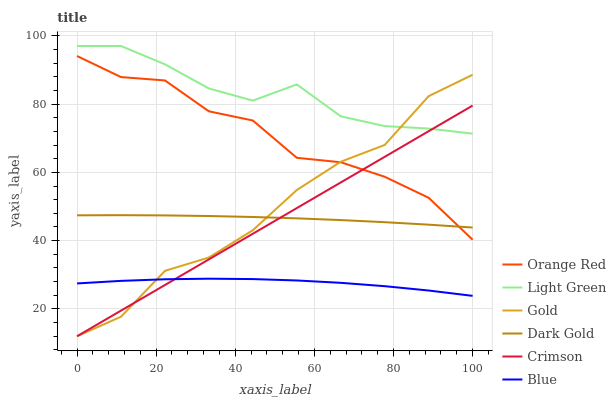Does Blue have the minimum area under the curve?
Answer yes or no. Yes. Does Light Green have the maximum area under the curve?
Answer yes or no. Yes. Does Gold have the minimum area under the curve?
Answer yes or no. No. Does Gold have the maximum area under the curve?
Answer yes or no. No. Is Crimson the smoothest?
Answer yes or no. Yes. Is Gold the roughest?
Answer yes or no. Yes. Is Dark Gold the smoothest?
Answer yes or no. No. Is Dark Gold the roughest?
Answer yes or no. No. Does Gold have the lowest value?
Answer yes or no. Yes. Does Dark Gold have the lowest value?
Answer yes or no. No. Does Light Green have the highest value?
Answer yes or no. Yes. Does Gold have the highest value?
Answer yes or no. No. Is Blue less than Orange Red?
Answer yes or no. Yes. Is Light Green greater than Dark Gold?
Answer yes or no. Yes. Does Crimson intersect Gold?
Answer yes or no. Yes. Is Crimson less than Gold?
Answer yes or no. No. Is Crimson greater than Gold?
Answer yes or no. No. Does Blue intersect Orange Red?
Answer yes or no. No. 